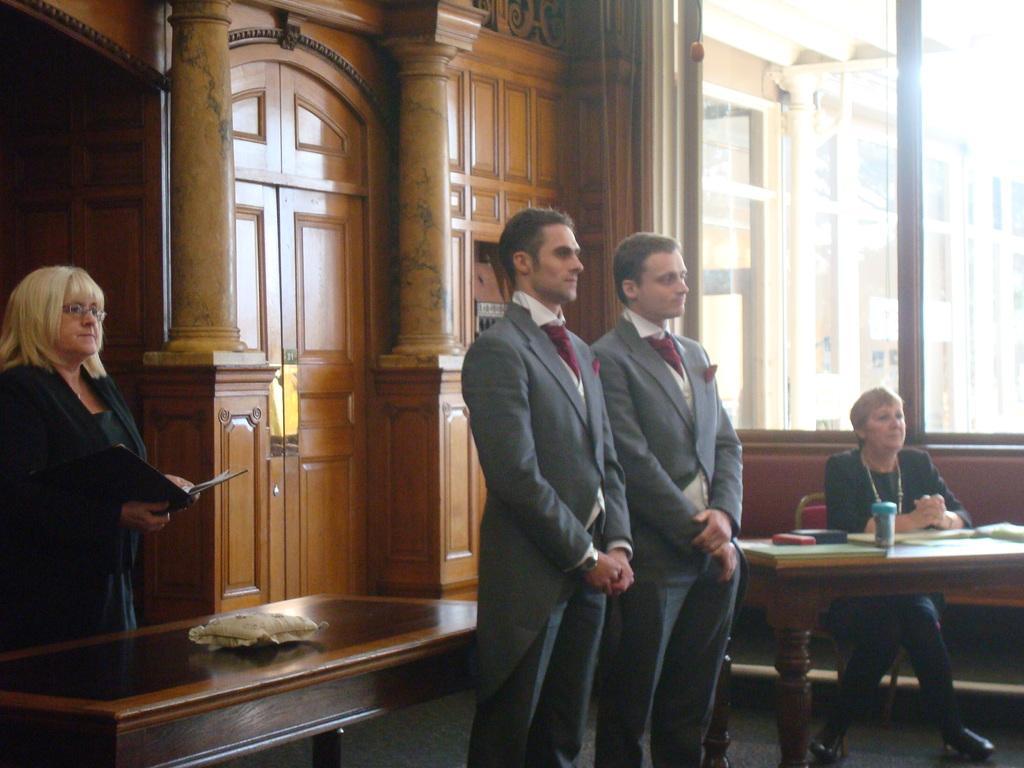How would you summarize this image in a sentence or two? In this picture these three persons standing. There is a person sitting on the chair. There are two tables. On the table we can see cup,book,box. These person holding a book. In this background we can see wall,pillar and glass window. From this glass window we can see building. 